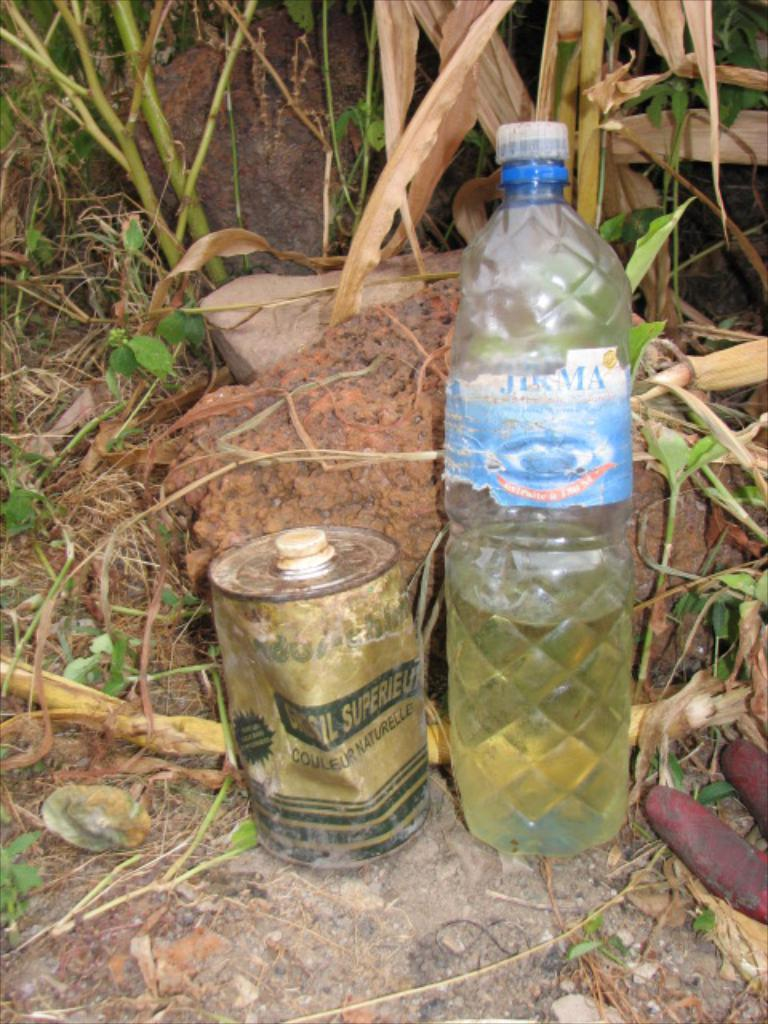What type of container is visible in the image? There is a water bottle and a can in the image. Can you describe the background of the image? There is a rock and plants in the background of the image. What type of train can be seen in the image? There is no train present in the image. Is there any indication of a wound or injury in the image? There is no indication of a wound or injury in the image. 